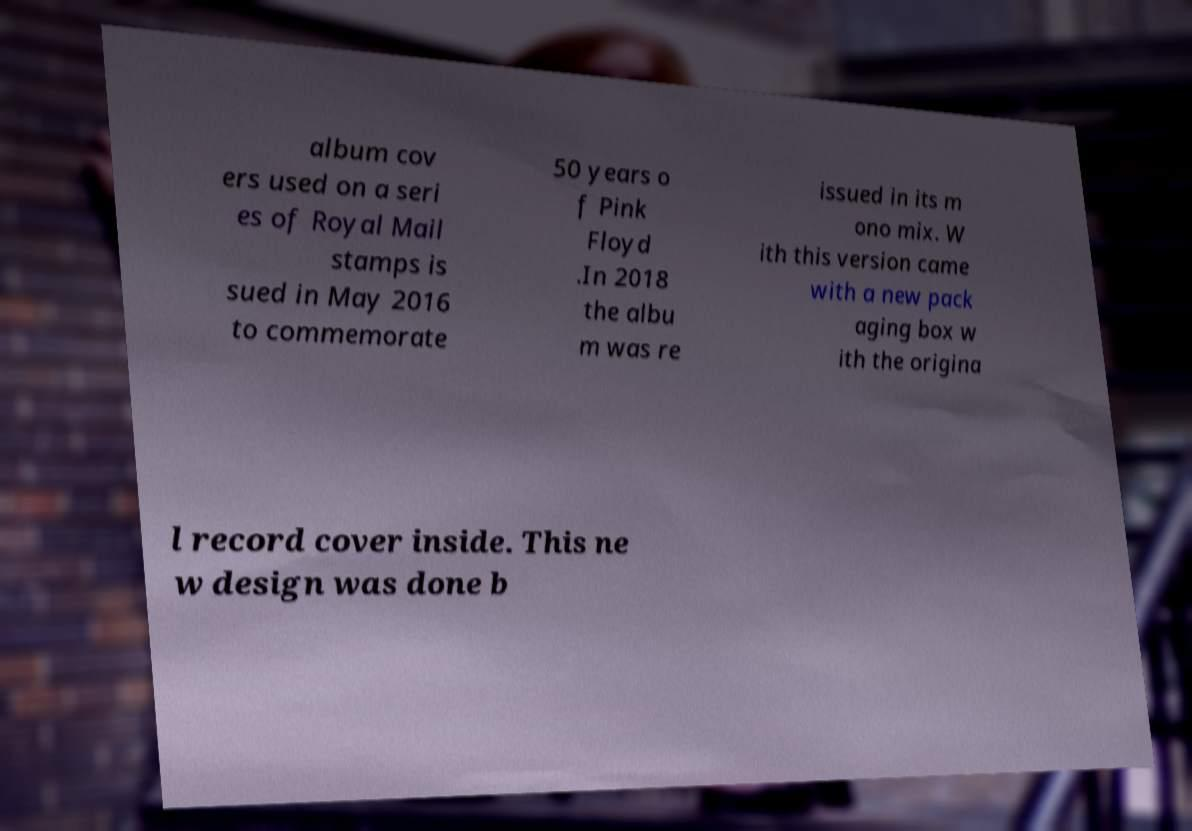Could you assist in decoding the text presented in this image and type it out clearly? album cov ers used on a seri es of Royal Mail stamps is sued in May 2016 to commemorate 50 years o f Pink Floyd .In 2018 the albu m was re issued in its m ono mix. W ith this version came with a new pack aging box w ith the origina l record cover inside. This ne w design was done b 